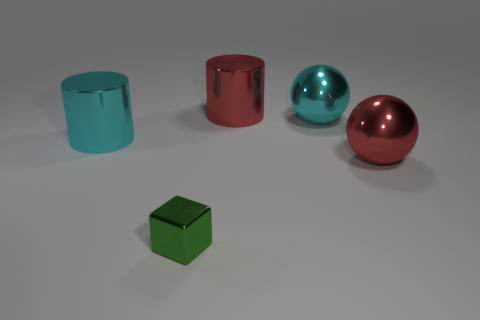Is the number of small green cubes that are in front of the metallic block greater than the number of red metal things to the left of the red sphere?
Offer a terse response. No. How many other objects are there of the same size as the cyan cylinder?
Give a very brief answer. 3. There is a red object that is behind the large shiny ball that is in front of the cyan metallic cylinder; how big is it?
Make the answer very short. Large. How many large objects are either red metal balls or green metal objects?
Provide a short and direct response. 1. There is a shiny thing that is in front of the large sphere right of the large cyan shiny thing right of the tiny shiny object; how big is it?
Ensure brevity in your answer.  Small. Is there anything else that has the same color as the tiny metal object?
Your answer should be very brief. No. What is the thing that is in front of the red metal thing that is in front of the cyan thing to the right of the tiny thing made of?
Ensure brevity in your answer.  Metal. Are there any other things that are made of the same material as the tiny green cube?
Keep it short and to the point. Yes. What number of things are on the right side of the red shiny cylinder and in front of the cyan metallic cylinder?
Your response must be concise. 1. What is the color of the big metallic sphere in front of the cyan metallic thing left of the metallic cube?
Keep it short and to the point. Red. 